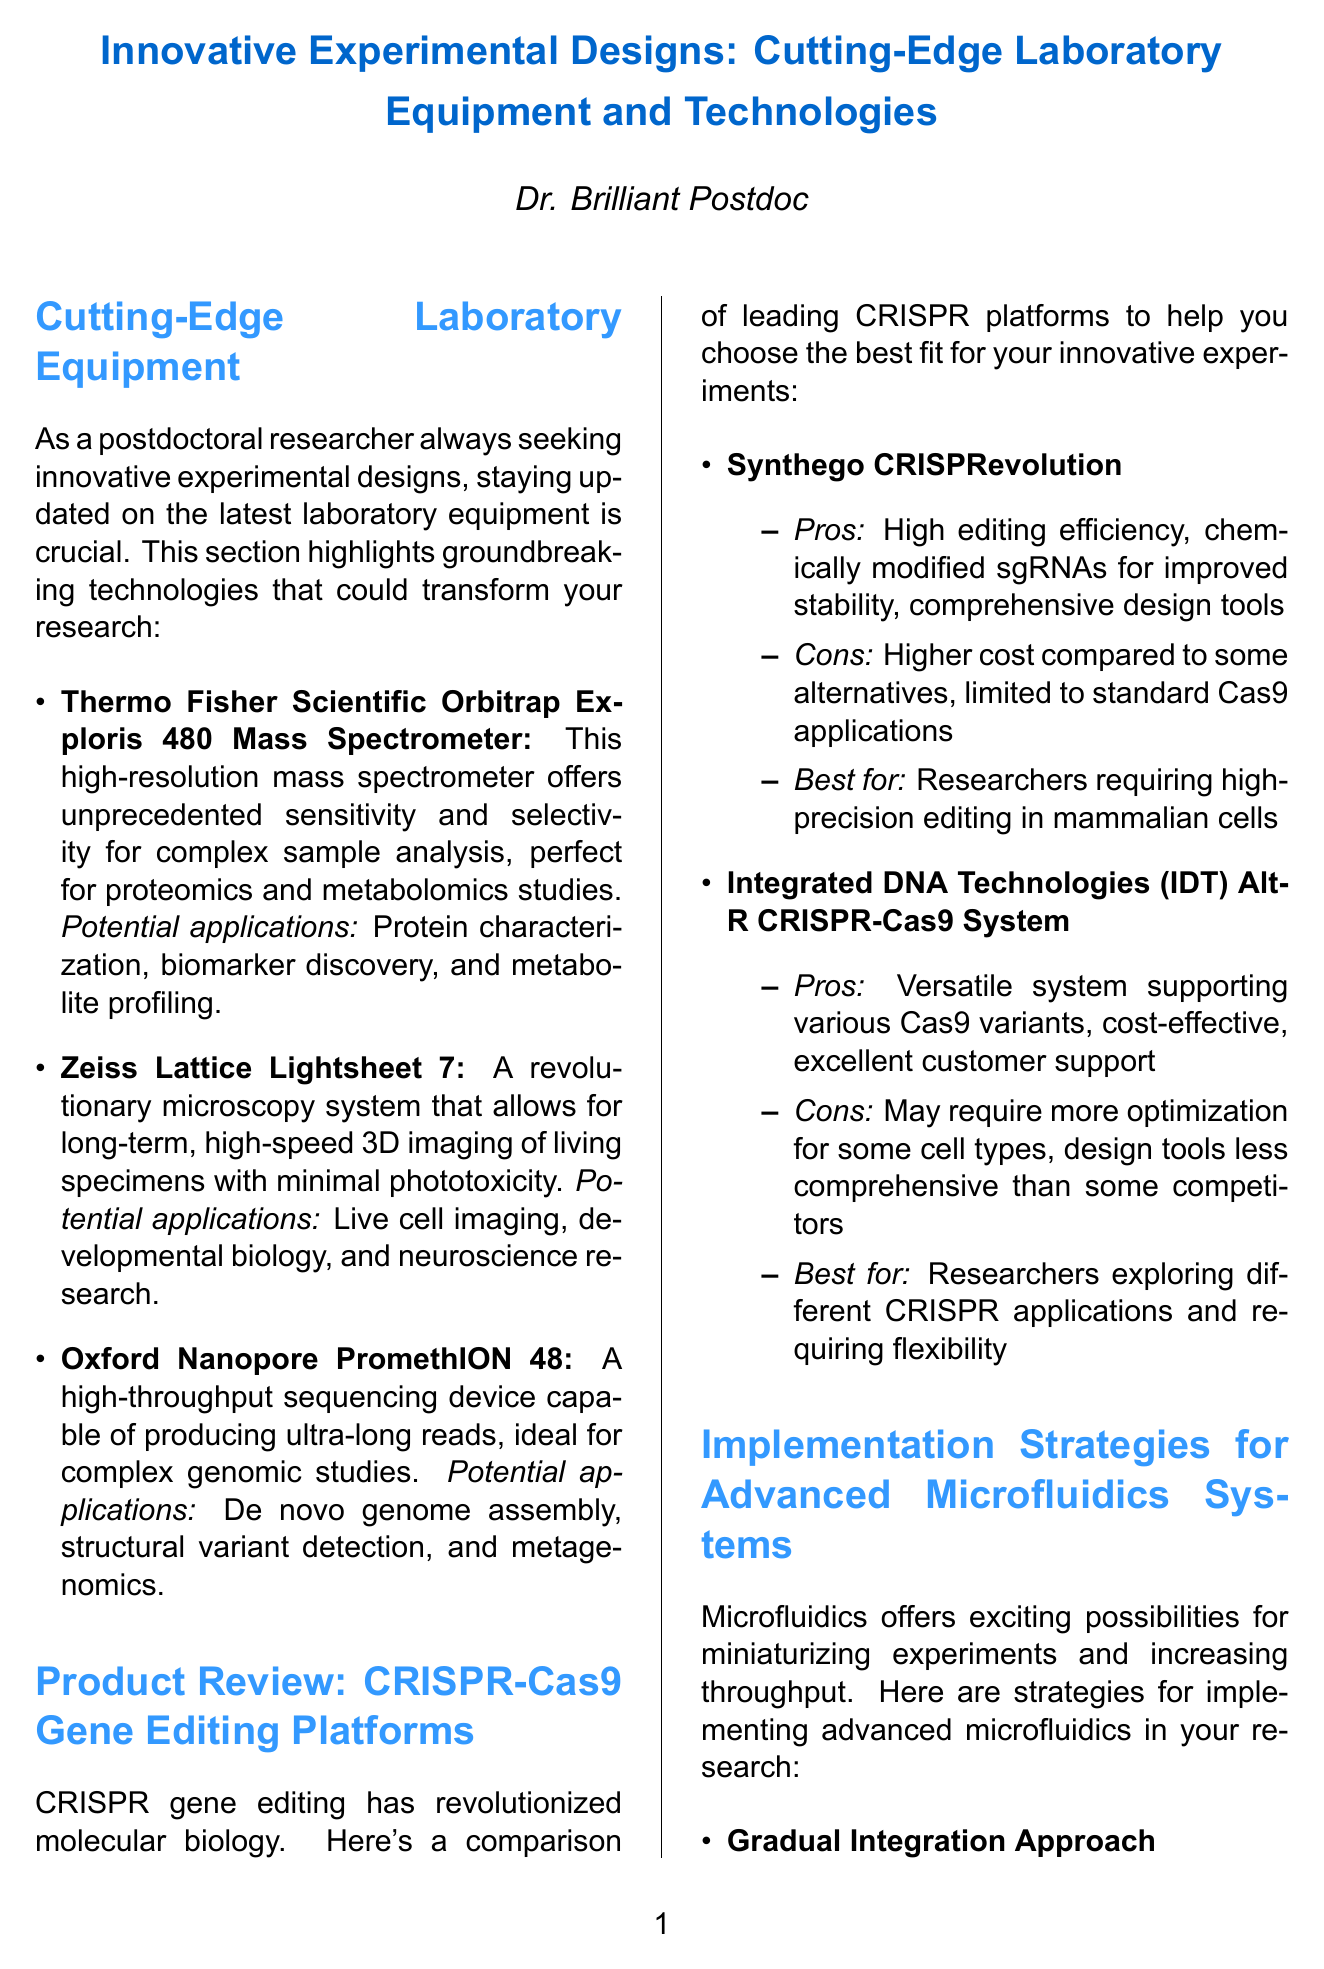What equipment is highlighted for proteomics and metabolomics studies? The document mentions the Thermo Fisher Scientific Orbitrap Exploris 480 Mass Spectrometer as equipment for proteomics and metabolomics studies.
Answer: Thermo Fisher Scientific Orbitrap Exploris 480 Mass Spectrometer Which microscopy system allows for minimal phototoxicity in living specimens? The document states that the Zeiss Lattice Lightsheet 7 allows for minimal phototoxicity when imaging living specimens.
Answer: Zeiss Lattice Lightsheet 7 What is the main advantage of the Synthego CRISPRevolution platform? The document lists high editing efficiency as a main advantage of the Synthego CRISPRevolution platform.
Answer: High editing efficiency What are the key players in Organ-on-a-Chip systems? The document identifies Emulate Bio, TissUse, and Mimetas as key players in Organ-on-a-Chip systems.
Answer: Emulate Bio, TissUse, Mimetas What approach is suggested for implementing advanced microfluidics? The document suggests a Gradual Integration Approach for implementing advanced microfluidics.
Answer: Gradual Integration Approach Which CRISPR platform is more cost-effective? The document states that the Integrated DNA Technologies Alt-R CRISPR-Cas9 System is more cost-effective compared to alternatives.
Answer: Integrated DNA Technologies Alt-R CRISPR-Cas9 System What system enables high-throughput sequencing of ultra-long reads? The Oxford Nanopore PromethION 48 is identified as the device enabling high-throughput sequencing of ultra-long reads.
Answer: Oxford Nanopore PromethION 48 Which technology incorporates time as the fourth dimension? The document mentions 4D Cell Culture Systems as the technology that incorporates time as the fourth dimension.
Answer: 4D Cell Culture Systems What integration method does the newsletter recommend for automation and high-throughput screening? The document recommends implementing robotic liquid handling systems for precise sample loading in automation and high-throughput screening.
Answer: Robotic liquid handling systems 